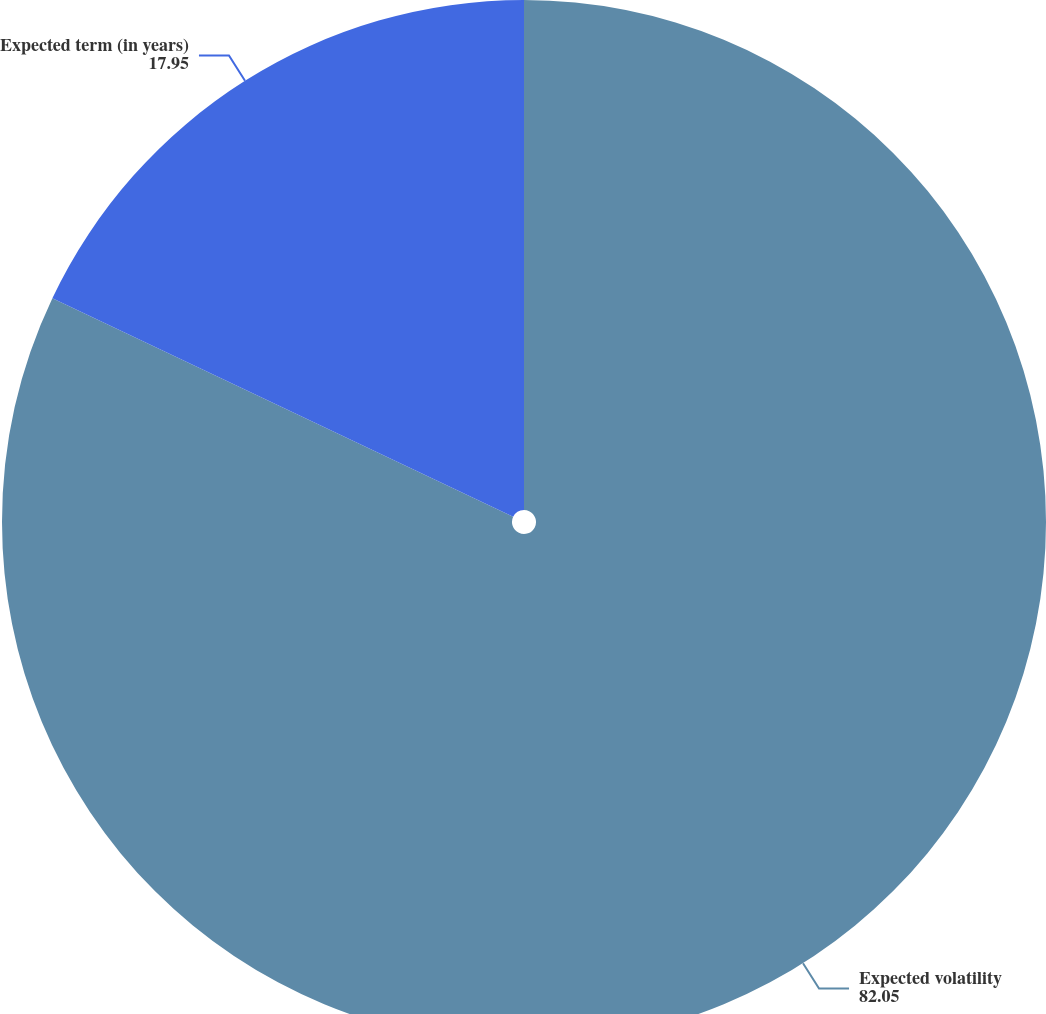Convert chart. <chart><loc_0><loc_0><loc_500><loc_500><pie_chart><fcel>Expected volatility<fcel>Expected term (in years)<nl><fcel>82.05%<fcel>17.95%<nl></chart> 